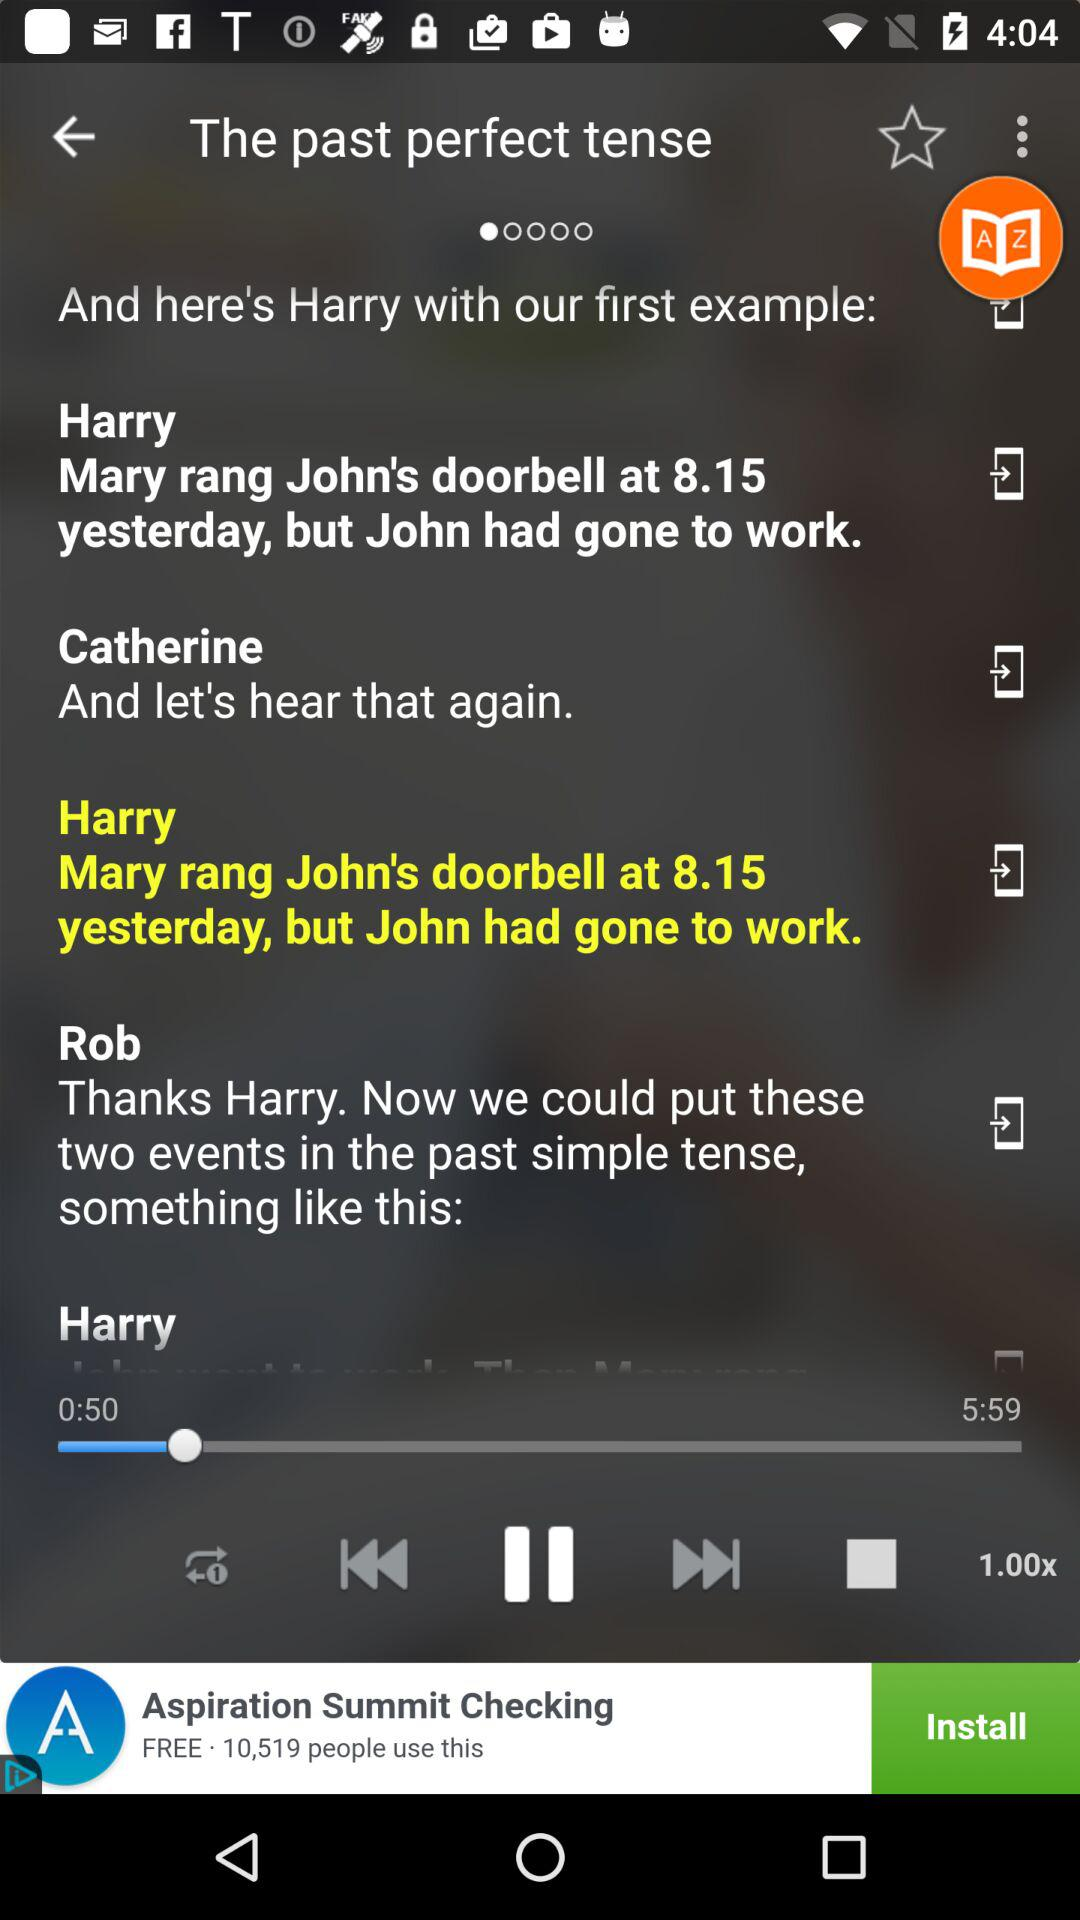What is the used tense? The used tense is past perfect. 